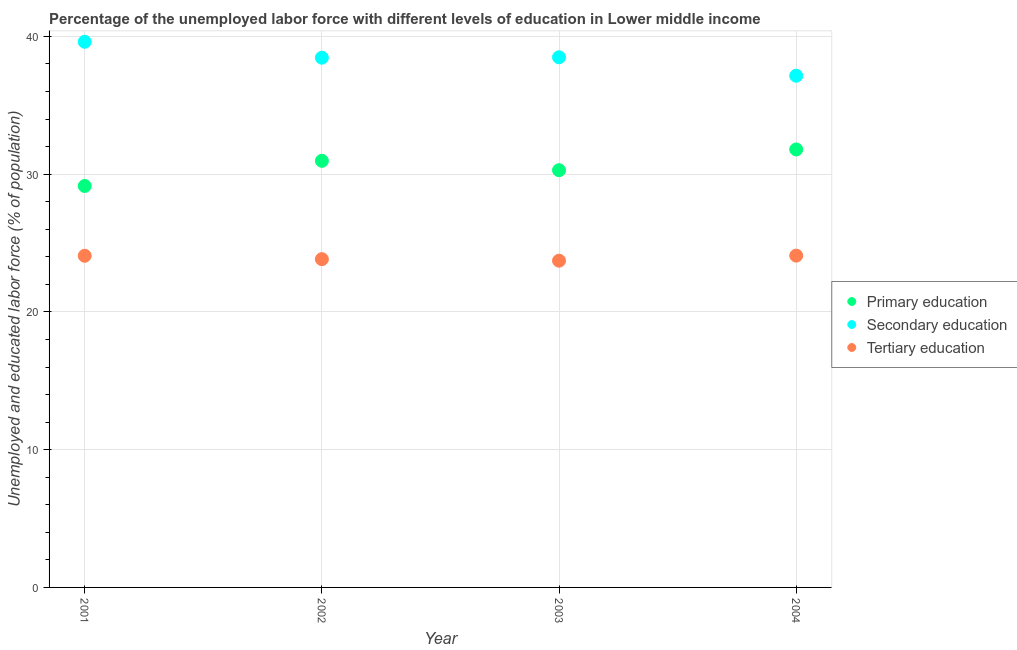How many different coloured dotlines are there?
Your answer should be compact. 3. What is the percentage of labor force who received tertiary education in 2001?
Make the answer very short. 24.08. Across all years, what is the maximum percentage of labor force who received primary education?
Your answer should be compact. 31.79. Across all years, what is the minimum percentage of labor force who received secondary education?
Make the answer very short. 37.14. In which year was the percentage of labor force who received tertiary education maximum?
Your response must be concise. 2004. In which year was the percentage of labor force who received primary education minimum?
Give a very brief answer. 2001. What is the total percentage of labor force who received primary education in the graph?
Provide a succinct answer. 122.19. What is the difference between the percentage of labor force who received tertiary education in 2001 and that in 2003?
Keep it short and to the point. 0.36. What is the difference between the percentage of labor force who received tertiary education in 2001 and the percentage of labor force who received secondary education in 2002?
Provide a short and direct response. -14.38. What is the average percentage of labor force who received primary education per year?
Provide a short and direct response. 30.55. In the year 2002, what is the difference between the percentage of labor force who received tertiary education and percentage of labor force who received primary education?
Offer a very short reply. -7.14. In how many years, is the percentage of labor force who received primary education greater than 26 %?
Make the answer very short. 4. What is the ratio of the percentage of labor force who received secondary education in 2003 to that in 2004?
Provide a succinct answer. 1.04. What is the difference between the highest and the second highest percentage of labor force who received primary education?
Ensure brevity in your answer.  0.83. What is the difference between the highest and the lowest percentage of labor force who received primary education?
Offer a terse response. 2.65. In how many years, is the percentage of labor force who received secondary education greater than the average percentage of labor force who received secondary education taken over all years?
Provide a succinct answer. 3. Is the sum of the percentage of labor force who received primary education in 2002 and 2004 greater than the maximum percentage of labor force who received tertiary education across all years?
Your answer should be very brief. Yes. Is it the case that in every year, the sum of the percentage of labor force who received primary education and percentage of labor force who received secondary education is greater than the percentage of labor force who received tertiary education?
Provide a succinct answer. Yes. Is the percentage of labor force who received tertiary education strictly less than the percentage of labor force who received primary education over the years?
Your answer should be compact. Yes. How many dotlines are there?
Offer a very short reply. 3. How many years are there in the graph?
Your response must be concise. 4. Does the graph contain any zero values?
Make the answer very short. No. How many legend labels are there?
Keep it short and to the point. 3. What is the title of the graph?
Give a very brief answer. Percentage of the unemployed labor force with different levels of education in Lower middle income. Does "Ages 65 and above" appear as one of the legend labels in the graph?
Your answer should be compact. No. What is the label or title of the X-axis?
Provide a short and direct response. Year. What is the label or title of the Y-axis?
Give a very brief answer. Unemployed and educated labor force (% of population). What is the Unemployed and educated labor force (% of population) of Primary education in 2001?
Your answer should be very brief. 29.14. What is the Unemployed and educated labor force (% of population) in Secondary education in 2001?
Ensure brevity in your answer.  39.61. What is the Unemployed and educated labor force (% of population) of Tertiary education in 2001?
Your answer should be compact. 24.08. What is the Unemployed and educated labor force (% of population) in Primary education in 2002?
Make the answer very short. 30.97. What is the Unemployed and educated labor force (% of population) of Secondary education in 2002?
Your response must be concise. 38.45. What is the Unemployed and educated labor force (% of population) of Tertiary education in 2002?
Your response must be concise. 23.83. What is the Unemployed and educated labor force (% of population) in Primary education in 2003?
Ensure brevity in your answer.  30.29. What is the Unemployed and educated labor force (% of population) of Secondary education in 2003?
Give a very brief answer. 38.48. What is the Unemployed and educated labor force (% of population) of Tertiary education in 2003?
Provide a succinct answer. 23.72. What is the Unemployed and educated labor force (% of population) in Primary education in 2004?
Give a very brief answer. 31.79. What is the Unemployed and educated labor force (% of population) of Secondary education in 2004?
Give a very brief answer. 37.14. What is the Unemployed and educated labor force (% of population) of Tertiary education in 2004?
Provide a short and direct response. 24.09. Across all years, what is the maximum Unemployed and educated labor force (% of population) of Primary education?
Provide a short and direct response. 31.79. Across all years, what is the maximum Unemployed and educated labor force (% of population) in Secondary education?
Offer a terse response. 39.61. Across all years, what is the maximum Unemployed and educated labor force (% of population) of Tertiary education?
Provide a succinct answer. 24.09. Across all years, what is the minimum Unemployed and educated labor force (% of population) in Primary education?
Provide a succinct answer. 29.14. Across all years, what is the minimum Unemployed and educated labor force (% of population) in Secondary education?
Offer a terse response. 37.14. Across all years, what is the minimum Unemployed and educated labor force (% of population) in Tertiary education?
Keep it short and to the point. 23.72. What is the total Unemployed and educated labor force (% of population) in Primary education in the graph?
Keep it short and to the point. 122.19. What is the total Unemployed and educated labor force (% of population) in Secondary education in the graph?
Make the answer very short. 153.69. What is the total Unemployed and educated labor force (% of population) of Tertiary education in the graph?
Provide a short and direct response. 95.71. What is the difference between the Unemployed and educated labor force (% of population) of Primary education in 2001 and that in 2002?
Keep it short and to the point. -1.83. What is the difference between the Unemployed and educated labor force (% of population) in Secondary education in 2001 and that in 2002?
Offer a terse response. 1.16. What is the difference between the Unemployed and educated labor force (% of population) of Tertiary education in 2001 and that in 2002?
Offer a very short reply. 0.25. What is the difference between the Unemployed and educated labor force (% of population) in Primary education in 2001 and that in 2003?
Provide a short and direct response. -1.15. What is the difference between the Unemployed and educated labor force (% of population) of Secondary education in 2001 and that in 2003?
Give a very brief answer. 1.13. What is the difference between the Unemployed and educated labor force (% of population) of Tertiary education in 2001 and that in 2003?
Your answer should be very brief. 0.36. What is the difference between the Unemployed and educated labor force (% of population) in Primary education in 2001 and that in 2004?
Your answer should be compact. -2.65. What is the difference between the Unemployed and educated labor force (% of population) in Secondary education in 2001 and that in 2004?
Your response must be concise. 2.46. What is the difference between the Unemployed and educated labor force (% of population) in Tertiary education in 2001 and that in 2004?
Offer a terse response. -0.01. What is the difference between the Unemployed and educated labor force (% of population) in Primary education in 2002 and that in 2003?
Your answer should be very brief. 0.68. What is the difference between the Unemployed and educated labor force (% of population) in Secondary education in 2002 and that in 2003?
Your answer should be compact. -0.03. What is the difference between the Unemployed and educated labor force (% of population) of Tertiary education in 2002 and that in 2003?
Give a very brief answer. 0.11. What is the difference between the Unemployed and educated labor force (% of population) in Primary education in 2002 and that in 2004?
Offer a very short reply. -0.83. What is the difference between the Unemployed and educated labor force (% of population) of Secondary education in 2002 and that in 2004?
Provide a short and direct response. 1.31. What is the difference between the Unemployed and educated labor force (% of population) in Tertiary education in 2002 and that in 2004?
Ensure brevity in your answer.  -0.26. What is the difference between the Unemployed and educated labor force (% of population) of Primary education in 2003 and that in 2004?
Ensure brevity in your answer.  -1.51. What is the difference between the Unemployed and educated labor force (% of population) in Secondary education in 2003 and that in 2004?
Your answer should be compact. 1.34. What is the difference between the Unemployed and educated labor force (% of population) in Tertiary education in 2003 and that in 2004?
Provide a short and direct response. -0.37. What is the difference between the Unemployed and educated labor force (% of population) in Primary education in 2001 and the Unemployed and educated labor force (% of population) in Secondary education in 2002?
Ensure brevity in your answer.  -9.31. What is the difference between the Unemployed and educated labor force (% of population) in Primary education in 2001 and the Unemployed and educated labor force (% of population) in Tertiary education in 2002?
Give a very brief answer. 5.31. What is the difference between the Unemployed and educated labor force (% of population) in Secondary education in 2001 and the Unemployed and educated labor force (% of population) in Tertiary education in 2002?
Keep it short and to the point. 15.78. What is the difference between the Unemployed and educated labor force (% of population) in Primary education in 2001 and the Unemployed and educated labor force (% of population) in Secondary education in 2003?
Your answer should be very brief. -9.34. What is the difference between the Unemployed and educated labor force (% of population) of Primary education in 2001 and the Unemployed and educated labor force (% of population) of Tertiary education in 2003?
Make the answer very short. 5.42. What is the difference between the Unemployed and educated labor force (% of population) in Secondary education in 2001 and the Unemployed and educated labor force (% of population) in Tertiary education in 2003?
Make the answer very short. 15.89. What is the difference between the Unemployed and educated labor force (% of population) of Primary education in 2001 and the Unemployed and educated labor force (% of population) of Secondary education in 2004?
Keep it short and to the point. -8. What is the difference between the Unemployed and educated labor force (% of population) of Primary education in 2001 and the Unemployed and educated labor force (% of population) of Tertiary education in 2004?
Your answer should be very brief. 5.06. What is the difference between the Unemployed and educated labor force (% of population) in Secondary education in 2001 and the Unemployed and educated labor force (% of population) in Tertiary education in 2004?
Give a very brief answer. 15.52. What is the difference between the Unemployed and educated labor force (% of population) of Primary education in 2002 and the Unemployed and educated labor force (% of population) of Secondary education in 2003?
Provide a short and direct response. -7.52. What is the difference between the Unemployed and educated labor force (% of population) in Primary education in 2002 and the Unemployed and educated labor force (% of population) in Tertiary education in 2003?
Offer a terse response. 7.25. What is the difference between the Unemployed and educated labor force (% of population) of Secondary education in 2002 and the Unemployed and educated labor force (% of population) of Tertiary education in 2003?
Provide a short and direct response. 14.73. What is the difference between the Unemployed and educated labor force (% of population) of Primary education in 2002 and the Unemployed and educated labor force (% of population) of Secondary education in 2004?
Give a very brief answer. -6.18. What is the difference between the Unemployed and educated labor force (% of population) in Primary education in 2002 and the Unemployed and educated labor force (% of population) in Tertiary education in 2004?
Offer a terse response. 6.88. What is the difference between the Unemployed and educated labor force (% of population) in Secondary education in 2002 and the Unemployed and educated labor force (% of population) in Tertiary education in 2004?
Provide a short and direct response. 14.37. What is the difference between the Unemployed and educated labor force (% of population) of Primary education in 2003 and the Unemployed and educated labor force (% of population) of Secondary education in 2004?
Make the answer very short. -6.86. What is the difference between the Unemployed and educated labor force (% of population) in Primary education in 2003 and the Unemployed and educated labor force (% of population) in Tertiary education in 2004?
Offer a very short reply. 6.2. What is the difference between the Unemployed and educated labor force (% of population) of Secondary education in 2003 and the Unemployed and educated labor force (% of population) of Tertiary education in 2004?
Your response must be concise. 14.4. What is the average Unemployed and educated labor force (% of population) in Primary education per year?
Provide a succinct answer. 30.55. What is the average Unemployed and educated labor force (% of population) of Secondary education per year?
Your answer should be compact. 38.42. What is the average Unemployed and educated labor force (% of population) of Tertiary education per year?
Your answer should be compact. 23.93. In the year 2001, what is the difference between the Unemployed and educated labor force (% of population) of Primary education and Unemployed and educated labor force (% of population) of Secondary education?
Ensure brevity in your answer.  -10.47. In the year 2001, what is the difference between the Unemployed and educated labor force (% of population) in Primary education and Unemployed and educated labor force (% of population) in Tertiary education?
Give a very brief answer. 5.07. In the year 2001, what is the difference between the Unemployed and educated labor force (% of population) in Secondary education and Unemployed and educated labor force (% of population) in Tertiary education?
Make the answer very short. 15.53. In the year 2002, what is the difference between the Unemployed and educated labor force (% of population) in Primary education and Unemployed and educated labor force (% of population) in Secondary education?
Provide a succinct answer. -7.49. In the year 2002, what is the difference between the Unemployed and educated labor force (% of population) in Primary education and Unemployed and educated labor force (% of population) in Tertiary education?
Provide a succinct answer. 7.14. In the year 2002, what is the difference between the Unemployed and educated labor force (% of population) of Secondary education and Unemployed and educated labor force (% of population) of Tertiary education?
Make the answer very short. 14.62. In the year 2003, what is the difference between the Unemployed and educated labor force (% of population) of Primary education and Unemployed and educated labor force (% of population) of Secondary education?
Provide a succinct answer. -8.2. In the year 2003, what is the difference between the Unemployed and educated labor force (% of population) of Primary education and Unemployed and educated labor force (% of population) of Tertiary education?
Offer a very short reply. 6.57. In the year 2003, what is the difference between the Unemployed and educated labor force (% of population) in Secondary education and Unemployed and educated labor force (% of population) in Tertiary education?
Make the answer very short. 14.76. In the year 2004, what is the difference between the Unemployed and educated labor force (% of population) in Primary education and Unemployed and educated labor force (% of population) in Secondary education?
Offer a terse response. -5.35. In the year 2004, what is the difference between the Unemployed and educated labor force (% of population) of Primary education and Unemployed and educated labor force (% of population) of Tertiary education?
Your response must be concise. 7.71. In the year 2004, what is the difference between the Unemployed and educated labor force (% of population) in Secondary education and Unemployed and educated labor force (% of population) in Tertiary education?
Keep it short and to the point. 13.06. What is the ratio of the Unemployed and educated labor force (% of population) of Primary education in 2001 to that in 2002?
Give a very brief answer. 0.94. What is the ratio of the Unemployed and educated labor force (% of population) of Secondary education in 2001 to that in 2002?
Keep it short and to the point. 1.03. What is the ratio of the Unemployed and educated labor force (% of population) of Tertiary education in 2001 to that in 2002?
Ensure brevity in your answer.  1.01. What is the ratio of the Unemployed and educated labor force (% of population) in Primary education in 2001 to that in 2003?
Provide a short and direct response. 0.96. What is the ratio of the Unemployed and educated labor force (% of population) in Secondary education in 2001 to that in 2003?
Your response must be concise. 1.03. What is the ratio of the Unemployed and educated labor force (% of population) of Tertiary education in 2001 to that in 2003?
Offer a very short reply. 1.01. What is the ratio of the Unemployed and educated labor force (% of population) of Primary education in 2001 to that in 2004?
Keep it short and to the point. 0.92. What is the ratio of the Unemployed and educated labor force (% of population) of Secondary education in 2001 to that in 2004?
Keep it short and to the point. 1.07. What is the ratio of the Unemployed and educated labor force (% of population) of Tertiary education in 2001 to that in 2004?
Provide a short and direct response. 1. What is the ratio of the Unemployed and educated labor force (% of population) in Primary education in 2002 to that in 2003?
Keep it short and to the point. 1.02. What is the ratio of the Unemployed and educated labor force (% of population) of Primary education in 2002 to that in 2004?
Your answer should be very brief. 0.97. What is the ratio of the Unemployed and educated labor force (% of population) in Secondary education in 2002 to that in 2004?
Your answer should be compact. 1.04. What is the ratio of the Unemployed and educated labor force (% of population) of Primary education in 2003 to that in 2004?
Keep it short and to the point. 0.95. What is the ratio of the Unemployed and educated labor force (% of population) of Secondary education in 2003 to that in 2004?
Your response must be concise. 1.04. What is the difference between the highest and the second highest Unemployed and educated labor force (% of population) in Primary education?
Your answer should be compact. 0.83. What is the difference between the highest and the second highest Unemployed and educated labor force (% of population) of Secondary education?
Provide a succinct answer. 1.13. What is the difference between the highest and the second highest Unemployed and educated labor force (% of population) of Tertiary education?
Keep it short and to the point. 0.01. What is the difference between the highest and the lowest Unemployed and educated labor force (% of population) of Primary education?
Offer a terse response. 2.65. What is the difference between the highest and the lowest Unemployed and educated labor force (% of population) in Secondary education?
Your answer should be very brief. 2.46. What is the difference between the highest and the lowest Unemployed and educated labor force (% of population) in Tertiary education?
Your answer should be compact. 0.37. 